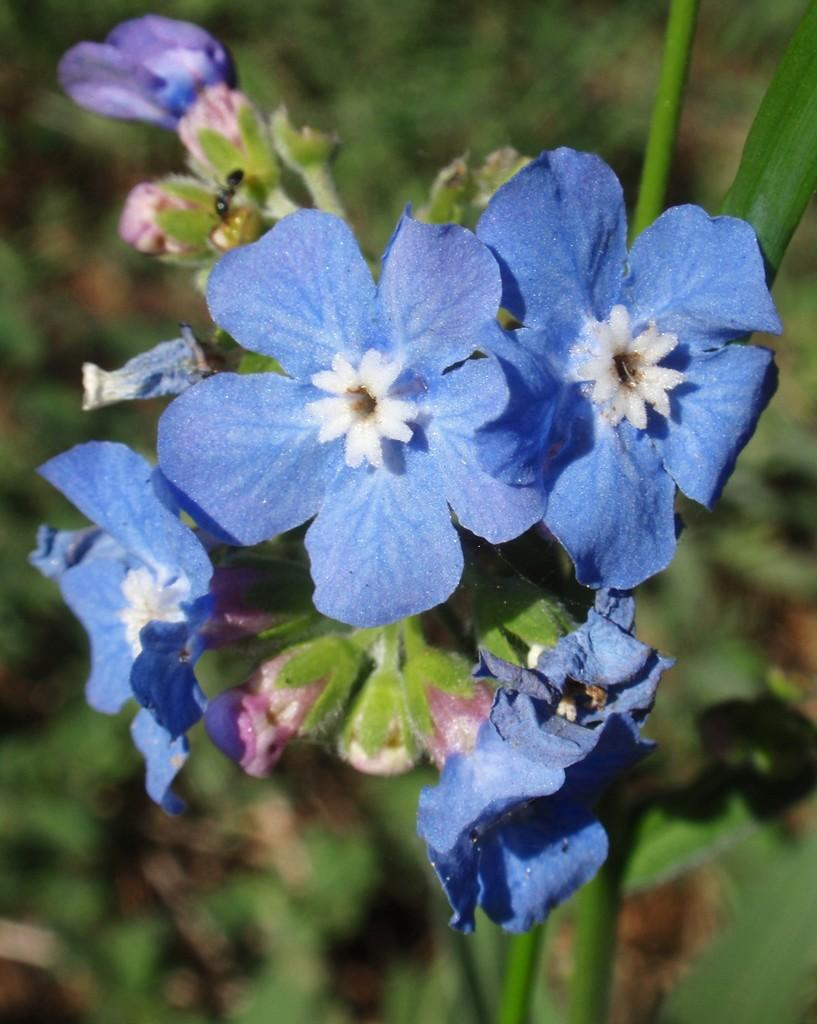What color are the flowers in the image? The flowers in the image are blue. What stage of growth are the flowers in the image? There are buds on a stem in the image, indicating that they are not fully bloomed yet. What type of insect can be seen on a flower in the image? There is an ant on a flower in the image. Can you describe the background of the image? The background of the image is blurred. What type of approval is being sought in the image? There is no indication of approval or any related activity in the image; it features flowers, buds, an ant, and a blurred background. 